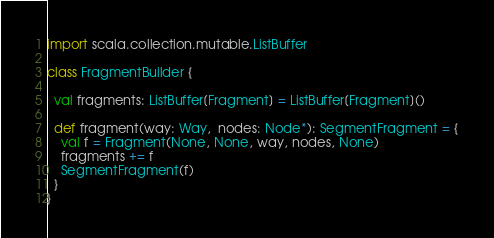<code> <loc_0><loc_0><loc_500><loc_500><_Scala_>
import scala.collection.mutable.ListBuffer

class FragmentBuilder {

  val fragments: ListBuffer[Fragment] = ListBuffer[Fragment]()

  def fragment(way: Way,  nodes: Node*): SegmentFragment = {
    val f = Fragment(None, None, way, nodes, None)
    fragments += f
    SegmentFragment(f)
  }
}
</code> 